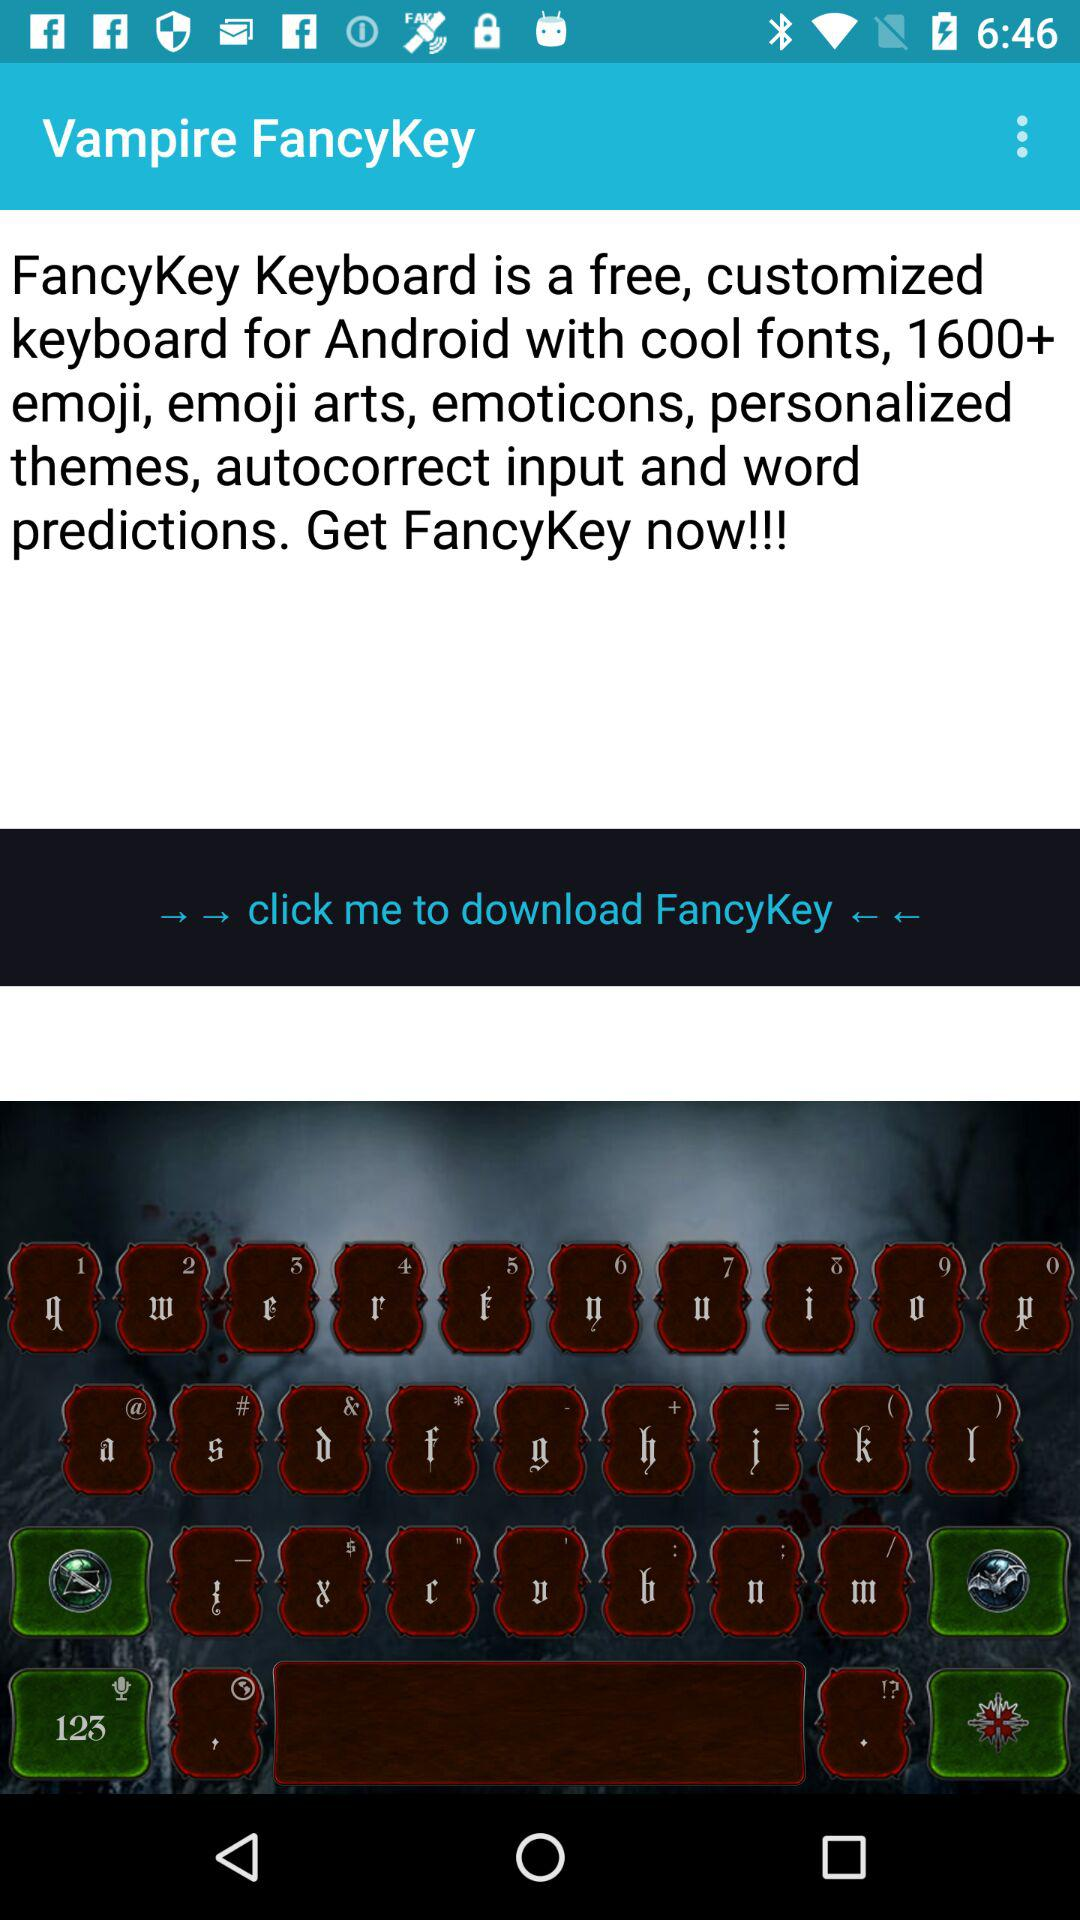How many emojis, emoticons, themes, and other characters are in the "Vampire FancyKey" keyboard? There are more than 1600 characters. 